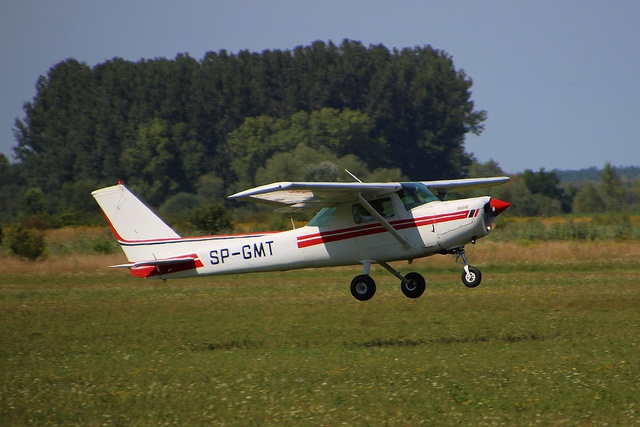Describe the objects in this image and their specific colors. I can see a airplane in gray, lightgray, black, and darkgreen tones in this image. 